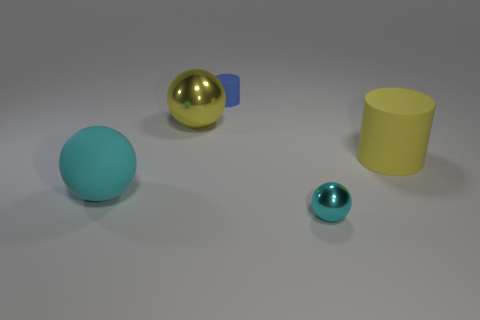Add 3 big brown cubes. How many objects exist? 8 Subtract all cylinders. How many objects are left? 3 Add 1 yellow rubber cylinders. How many yellow rubber cylinders exist? 2 Subtract 0 brown spheres. How many objects are left? 5 Subtract all big yellow metal balls. Subtract all big objects. How many objects are left? 1 Add 4 tiny objects. How many tiny objects are left? 6 